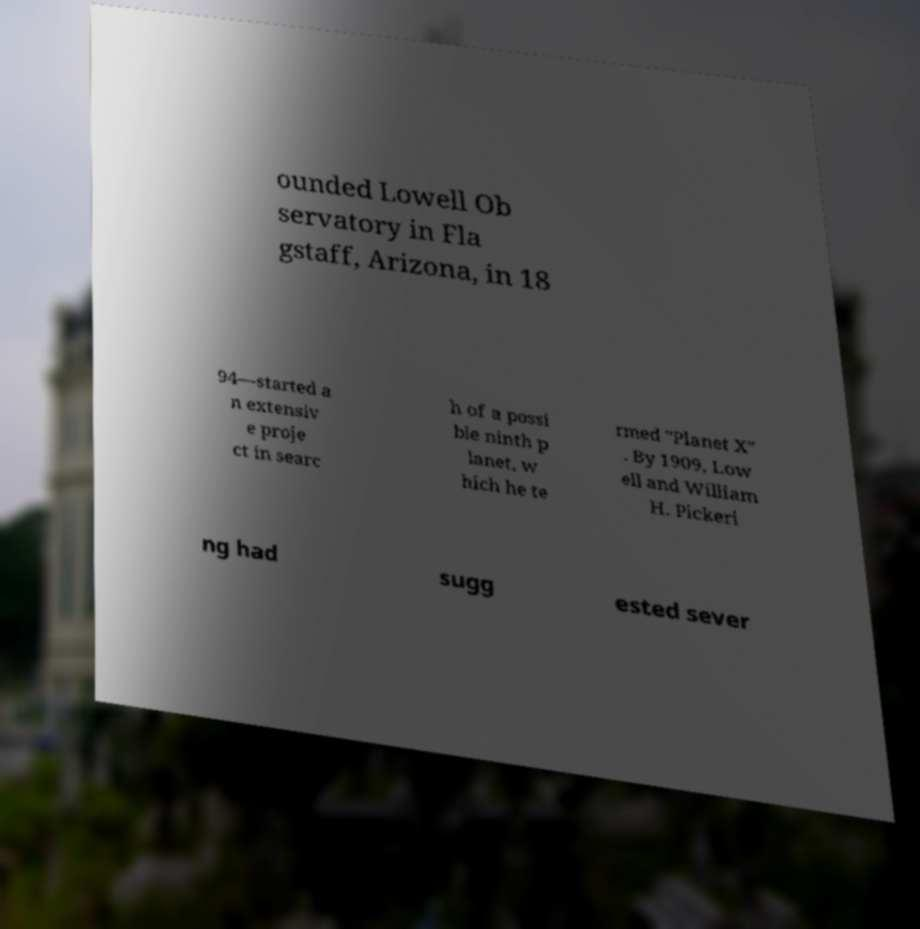Could you assist in decoding the text presented in this image and type it out clearly? ounded Lowell Ob servatory in Fla gstaff, Arizona, in 18 94—started a n extensiv e proje ct in searc h of a possi ble ninth p lanet, w hich he te rmed "Planet X" . By 1909, Low ell and William H. Pickeri ng had sugg ested sever 